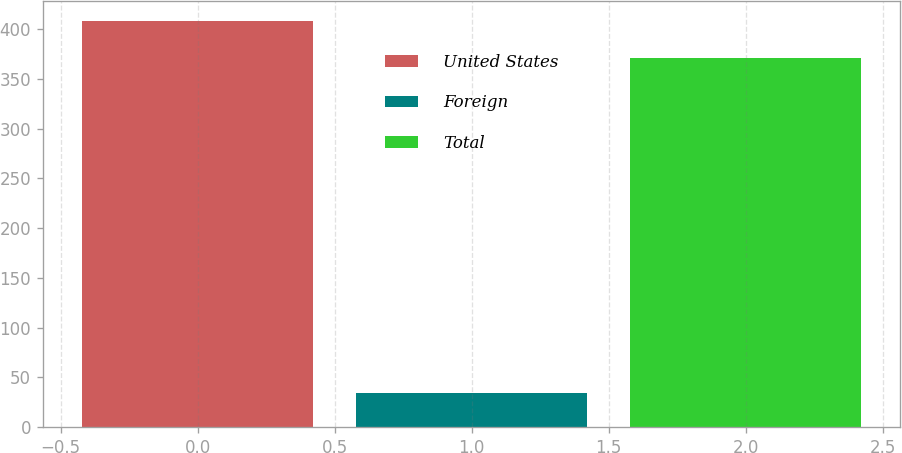Convert chart to OTSL. <chart><loc_0><loc_0><loc_500><loc_500><bar_chart><fcel>United States<fcel>Foreign<fcel>Total<nl><fcel>408.1<fcel>34<fcel>371<nl></chart> 